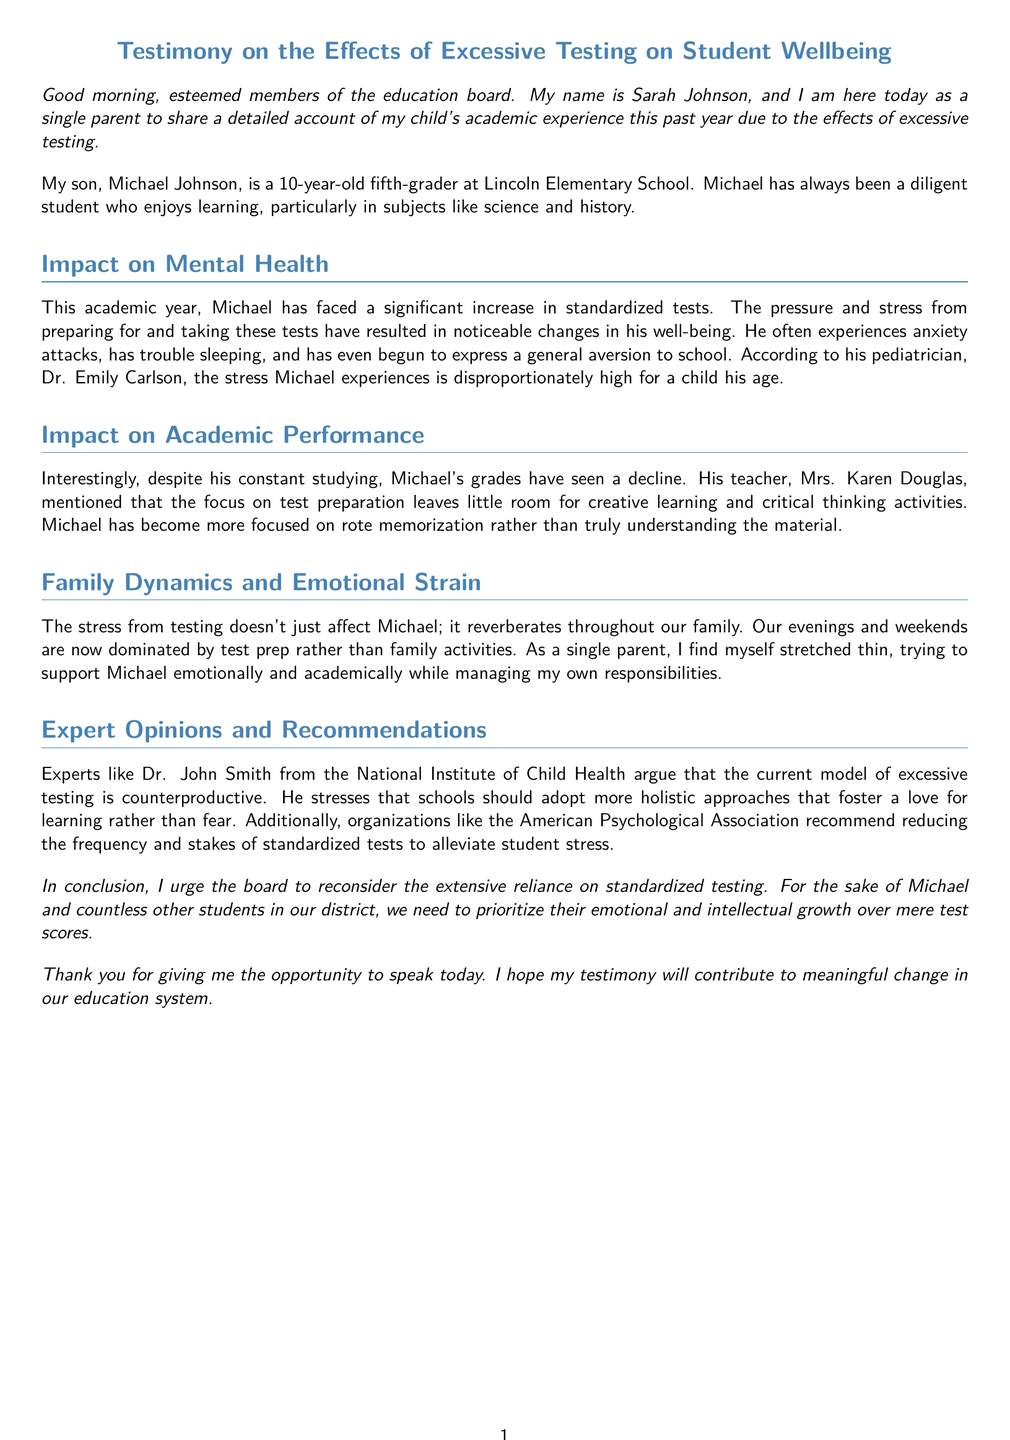What is Michael's grade level? Michael is a fifth-grader at Lincoln Elementary School.
Answer: fifth-grader Who is the speaker's son? The speaker's son is named Michael Johnson.
Answer: Michael Johnson What negative impact has Michael experienced due to testing? The pressure and stress from preparing for and taking tests have led to anxiety attacks.
Answer: anxiety attacks Who is the pediatrician mentioned in the testimony? The pediatrician who assessed Michael's stress is named Dr. Emily Carlson.
Answer: Dr. Emily Carlson What does Michael's teacher state about test preparation? Mrs. Karen Douglas mentioned that the focus on test preparation leaves little room for creative learning.
Answer: creative learning What approach do experts recommend instead of excessive testing? Experts argue for adopting more holistic approaches that foster a love for learning.
Answer: holistic approaches What has changed in the family's weekend activities? The family's weekends are now dominated by test prep rather than family activities.
Answer: test prep What organization recommends reducing the frequency of standardized tests? The American Psychological Association recommends reducing the frequency and stakes of tests.
Answer: American Psychological Association What is the overall conclusion the speaker urges the board to consider? The speaker urges the board to reconsider the reliance on standardized testing.
Answer: reconsider the reliance on standardized testing 